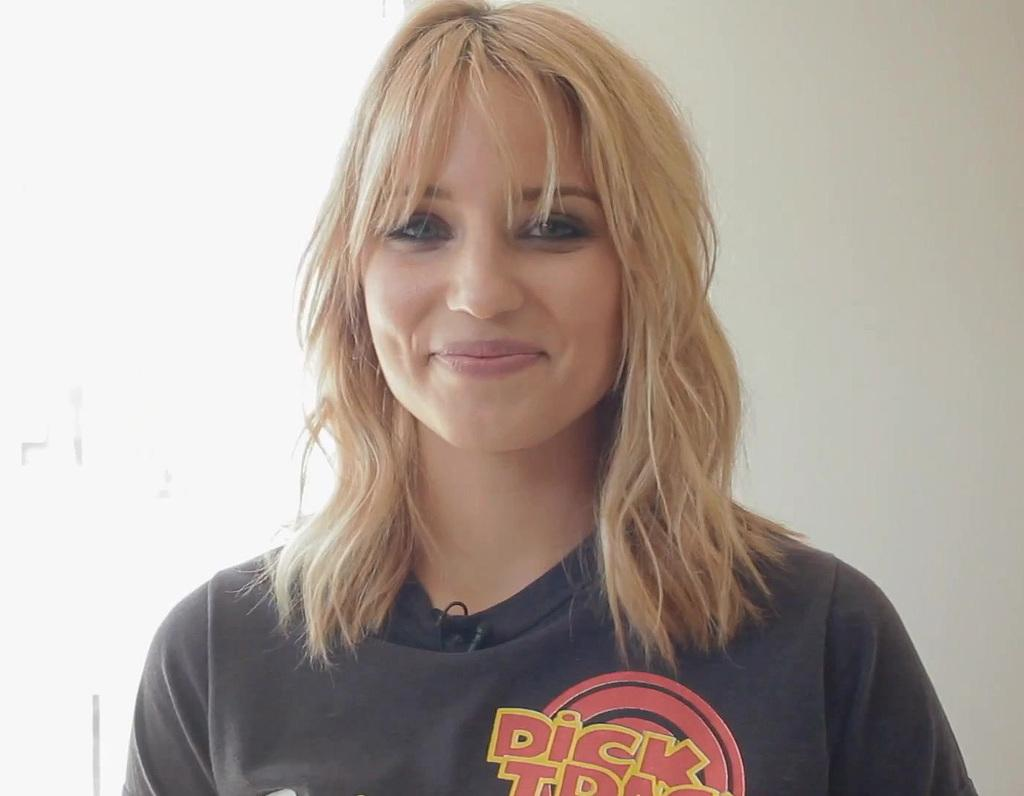Provide a one-sentence caption for the provided image. a beautiful blonde haired lady wearing a dick tracy shit. 